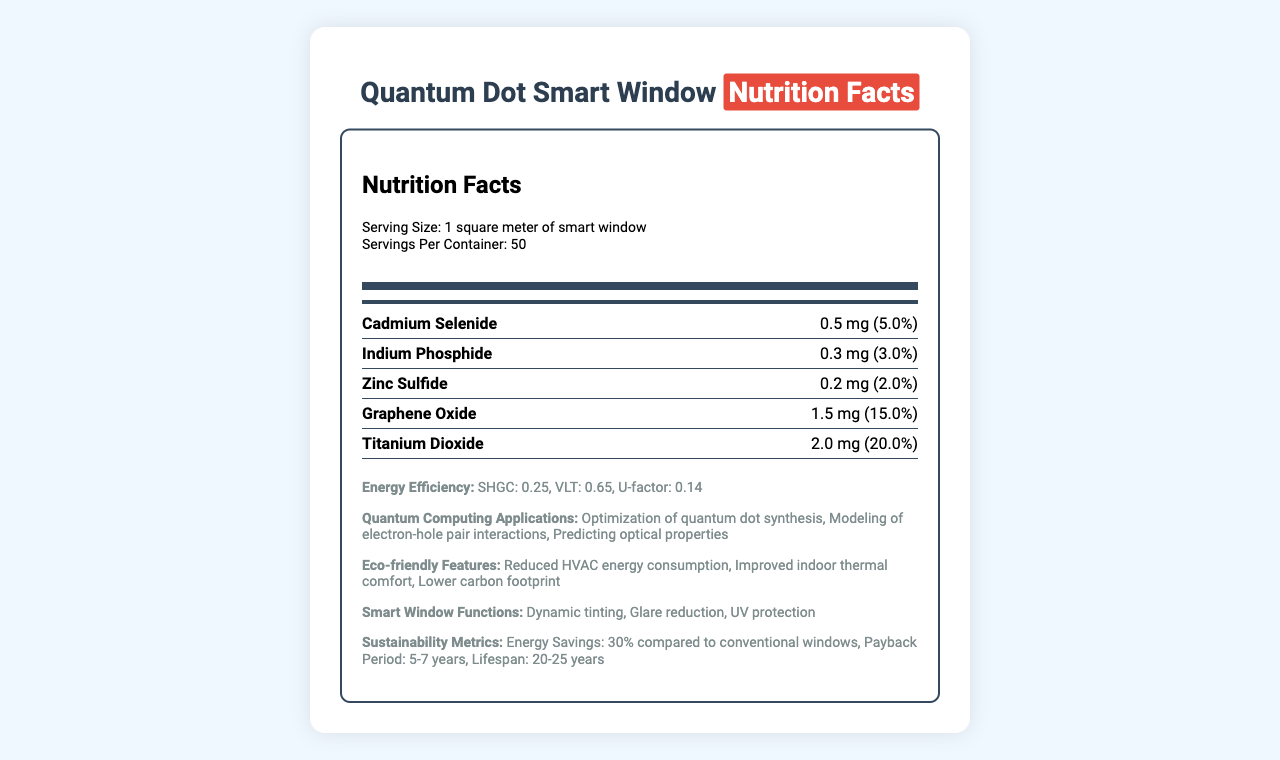what is the serving size for the smart window? The document states that the serving size is "1 square meter of smart window."
Answer: 1 square meter how much Cadmium Selenide is present per serving? The nutrient content section lists Cadmium Selenide with an amount of 0.5 mg per serving.
Answer: 0.5 mg what is the solar heat gain coefficient (SHGC) for the smart window? The energy efficiency section specifies the solar heat gain coefficient as 0.25.
Answer: 0.25 what is the total daily value percentage for Graphene Oxide? The document lists Graphene Oxide with a daily value of 0.15, which converts to 15%.
Answer: 15% how many servings per container are available for the smart windows? The document mentions that there are 50 servings per container.
Answer: 50 what is the primary synthesis method used in the manufacturing process? A. Vapor Deposition B. Plasma Synthesis C. Colloidal Quantum Dot Synthesis The document states the synthesis method as "Colloidal Quantum Dot Synthesis."
Answer: C. Colloidal Quantum Dot Synthesis which of the following is NOT listed as a quantum computing application in the document? A. Optimization of quantum dot synthesis B. Data encryption C. Modeling of electron-hole pair interactions The document lists "Optimization of quantum dot synthesis," "Modeling of electron-hole pair interactions," and "Predicting optical properties" as quantum computing applications, but not data encryption.
Answer: B. Data encryption does the document mention dynamic tinting as a smart window function? The smart window functions section includes "Dynamic tinting" as a feature.
Answer: Yes summarize the main focus of the document. The document includes sections on nutrient content, energy efficiency, quantum computing applications, eco-friendly features, smart window functions, the manufacturing process, and sustainability metrics. It aims to inform about the composition and benefits of quantum dot smart windows.
Answer: The document provides detailed information about the nutrient content analysis of quantum dots used in smart windows, focusing on their energy efficiency, quantum computing applications, eco-friendly features, manufacturing process, and sustainability metrics. what are the u-factor and visible light transmittance values for the smart window? The energy efficiency section lists the U-factor as 0.14 and the visible light transmittance as 0.65.
Answer: U-factor: 0.14, Visible Light Transmittance: 0.65 what are the listed eco-friendly features of the smart windows? The eco-friendly features section highlights "Reduced HVAC energy consumption," "Improved indoor thermal comfort," and "Lower carbon footprint."
Answer: Reduced HVAC energy consumption, Improved indoor thermal comfort, Lower carbon footprint what is the payback period for the smart windows? The sustainability metrics section specifies the payback period as "5-7 years."
Answer: 5-7 years how much Zinc Sulfide is present in the smart window per serving? The nutrient content section lists Zinc Sulfide with an amount of 0.2 mg per serving.
Answer: 0.2 mg what is the energy savings percentage compared to conventional windows? The sustainability metrics section states that energy savings are 30% compared to conventional windows.
Answer: 30% what is the lifespan of the smart windows? The document lists the lifespan of the smart windows as "20-25 years."
Answer: 20-25 years which element has the highest daily value percentage listed in the document? A. Cadmium Selenide B. Indium Phosphide C. Zinc Sulfide D. Graphene Oxide E. Titanium Dioxide The document lists Titanium Dioxide with the highest daily value percentage of 0.2, which is 20%.
Answer: E. Titanium Dioxide does the document provide information on the environmental impact of the quantum dot synthesis? The document does not specifically discuss the environmental impact of the quantum dot synthesis process.
Answer: Not enough information 